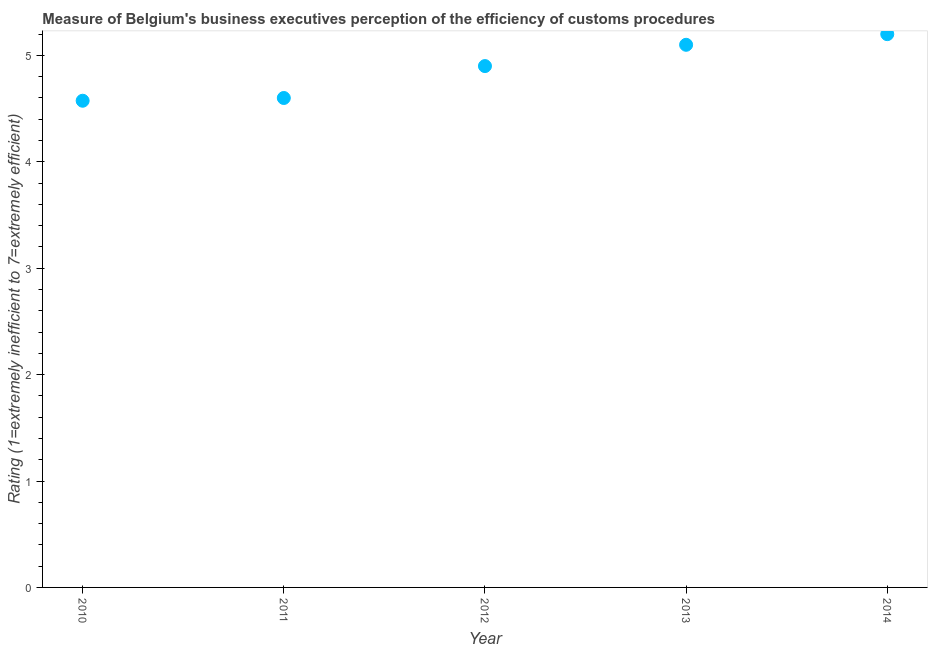What is the rating measuring burden of customs procedure in 2010?
Provide a short and direct response. 4.57. Across all years, what is the maximum rating measuring burden of customs procedure?
Offer a terse response. 5.2. Across all years, what is the minimum rating measuring burden of customs procedure?
Offer a terse response. 4.57. What is the sum of the rating measuring burden of customs procedure?
Ensure brevity in your answer.  24.37. What is the difference between the rating measuring burden of customs procedure in 2012 and 2013?
Offer a terse response. -0.2. What is the average rating measuring burden of customs procedure per year?
Provide a succinct answer. 4.87. What is the ratio of the rating measuring burden of customs procedure in 2013 to that in 2014?
Your answer should be very brief. 0.98. Is the rating measuring burden of customs procedure in 2013 less than that in 2014?
Provide a succinct answer. Yes. Is the difference between the rating measuring burden of customs procedure in 2012 and 2014 greater than the difference between any two years?
Offer a very short reply. No. What is the difference between the highest and the second highest rating measuring burden of customs procedure?
Your answer should be compact. 0.1. What is the difference between the highest and the lowest rating measuring burden of customs procedure?
Your answer should be very brief. 0.63. Does the rating measuring burden of customs procedure monotonically increase over the years?
Keep it short and to the point. Yes. How many dotlines are there?
Provide a succinct answer. 1. How many years are there in the graph?
Your answer should be very brief. 5. Are the values on the major ticks of Y-axis written in scientific E-notation?
Ensure brevity in your answer.  No. What is the title of the graph?
Provide a succinct answer. Measure of Belgium's business executives perception of the efficiency of customs procedures. What is the label or title of the Y-axis?
Your answer should be very brief. Rating (1=extremely inefficient to 7=extremely efficient). What is the Rating (1=extremely inefficient to 7=extremely efficient) in 2010?
Offer a very short reply. 4.57. What is the Rating (1=extremely inefficient to 7=extremely efficient) in 2011?
Provide a short and direct response. 4.6. What is the Rating (1=extremely inefficient to 7=extremely efficient) in 2012?
Keep it short and to the point. 4.9. What is the Rating (1=extremely inefficient to 7=extremely efficient) in 2013?
Provide a succinct answer. 5.1. What is the Rating (1=extremely inefficient to 7=extremely efficient) in 2014?
Offer a terse response. 5.2. What is the difference between the Rating (1=extremely inefficient to 7=extremely efficient) in 2010 and 2011?
Give a very brief answer. -0.03. What is the difference between the Rating (1=extremely inefficient to 7=extremely efficient) in 2010 and 2012?
Ensure brevity in your answer.  -0.33. What is the difference between the Rating (1=extremely inefficient to 7=extremely efficient) in 2010 and 2013?
Ensure brevity in your answer.  -0.53. What is the difference between the Rating (1=extremely inefficient to 7=extremely efficient) in 2010 and 2014?
Your answer should be compact. -0.63. What is the difference between the Rating (1=extremely inefficient to 7=extremely efficient) in 2011 and 2013?
Offer a very short reply. -0.5. What is the difference between the Rating (1=extremely inefficient to 7=extremely efficient) in 2011 and 2014?
Provide a succinct answer. -0.6. What is the difference between the Rating (1=extremely inefficient to 7=extremely efficient) in 2012 and 2014?
Offer a terse response. -0.3. What is the difference between the Rating (1=extremely inefficient to 7=extremely efficient) in 2013 and 2014?
Keep it short and to the point. -0.1. What is the ratio of the Rating (1=extremely inefficient to 7=extremely efficient) in 2010 to that in 2011?
Your response must be concise. 0.99. What is the ratio of the Rating (1=extremely inefficient to 7=extremely efficient) in 2010 to that in 2012?
Make the answer very short. 0.93. What is the ratio of the Rating (1=extremely inefficient to 7=extremely efficient) in 2010 to that in 2013?
Offer a terse response. 0.9. What is the ratio of the Rating (1=extremely inefficient to 7=extremely efficient) in 2011 to that in 2012?
Give a very brief answer. 0.94. What is the ratio of the Rating (1=extremely inefficient to 7=extremely efficient) in 2011 to that in 2013?
Offer a terse response. 0.9. What is the ratio of the Rating (1=extremely inefficient to 7=extremely efficient) in 2011 to that in 2014?
Give a very brief answer. 0.89. What is the ratio of the Rating (1=extremely inefficient to 7=extremely efficient) in 2012 to that in 2014?
Offer a very short reply. 0.94. What is the ratio of the Rating (1=extremely inefficient to 7=extremely efficient) in 2013 to that in 2014?
Your response must be concise. 0.98. 